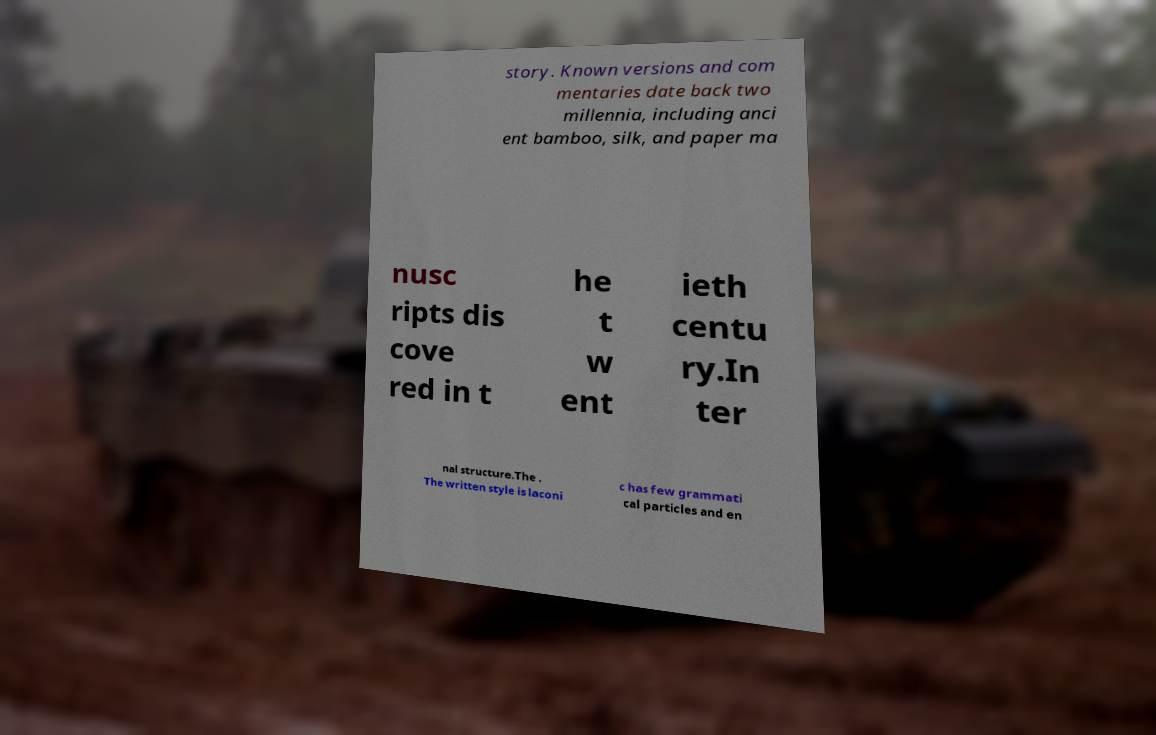For documentation purposes, I need the text within this image transcribed. Could you provide that? story. Known versions and com mentaries date back two millennia, including anci ent bamboo, silk, and paper ma nusc ripts dis cove red in t he t w ent ieth centu ry.In ter nal structure.The . The written style is laconi c has few grammati cal particles and en 